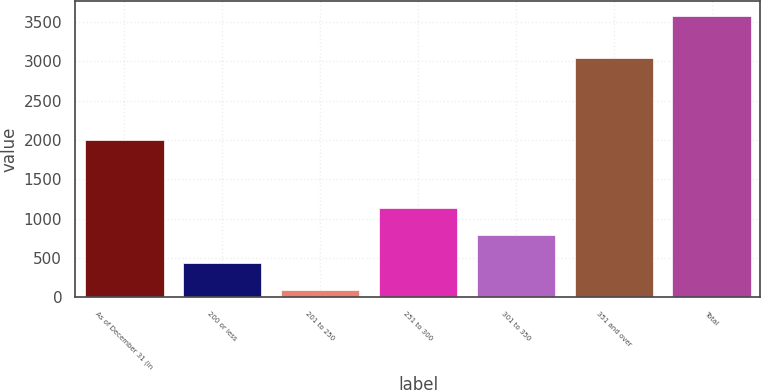Convert chart. <chart><loc_0><loc_0><loc_500><loc_500><bar_chart><fcel>As of December 31 (in<fcel>200 or less<fcel>201 to 250<fcel>251 to 300<fcel>301 to 350<fcel>351 and over<fcel>Total<nl><fcel>2006<fcel>441.64<fcel>92.6<fcel>1139.72<fcel>790.68<fcel>3045.3<fcel>3583<nl></chart> 